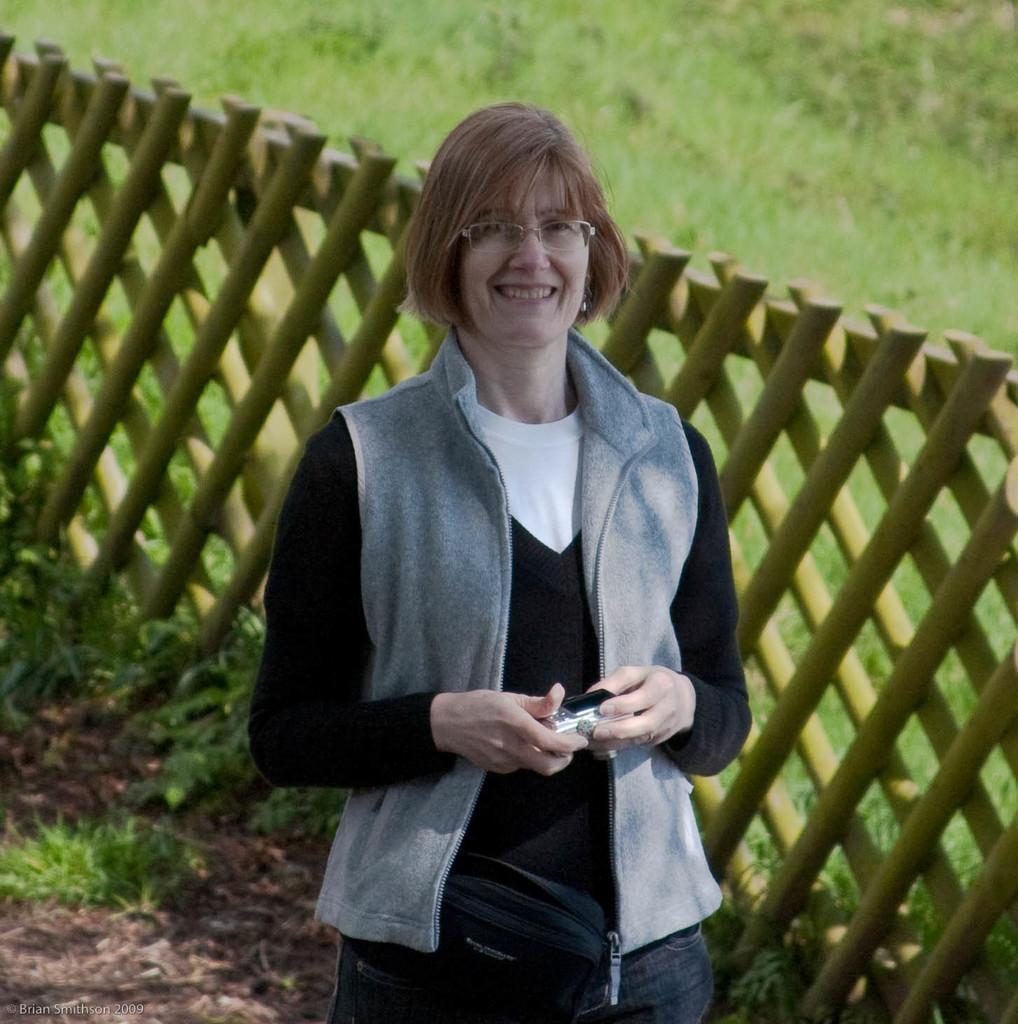Please provide a concise description of this image. i can see a woman standing wearing specs ,smiling , holding a camera and she is wearing a jacket and also behind her i can see a green color garden and also i can see a grill which is build with wooden. 